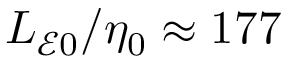<formula> <loc_0><loc_0><loc_500><loc_500>L _ { \mathcal { E } 0 } / \eta _ { 0 } \approx 1 7 7</formula> 